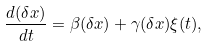Convert formula to latex. <formula><loc_0><loc_0><loc_500><loc_500>\frac { d ( \delta x ) } { d t } = \beta ( \delta x ) + \gamma ( \delta x ) \xi ( t ) ,</formula> 